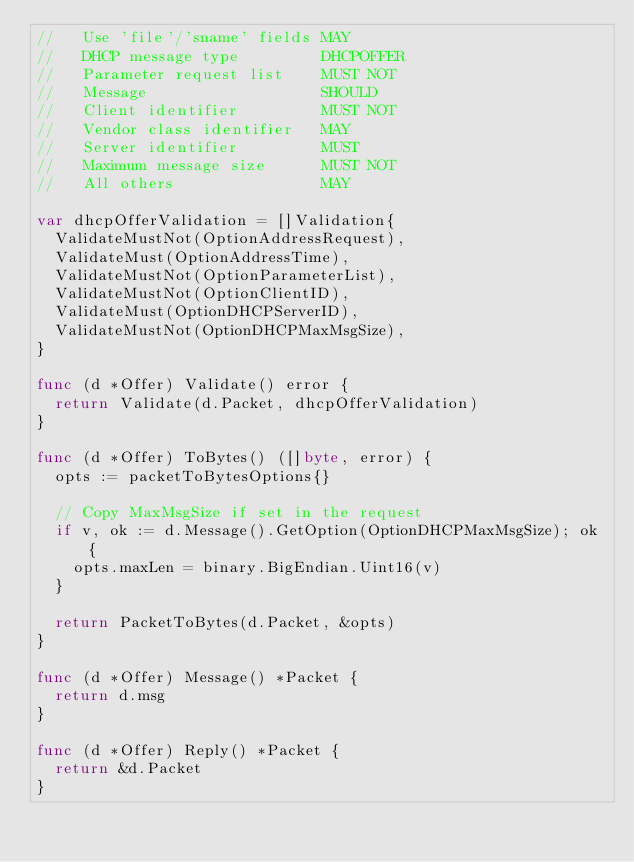Convert code to text. <code><loc_0><loc_0><loc_500><loc_500><_Go_>//   Use 'file'/'sname' fields MAY
//   DHCP message type         DHCPOFFER
//   Parameter request list    MUST NOT
//   Message                   SHOULD
//   Client identifier         MUST NOT
//   Vendor class identifier   MAY
//   Server identifier         MUST
//   Maximum message size      MUST NOT
//   All others                MAY

var dhcpOfferValidation = []Validation{
	ValidateMustNot(OptionAddressRequest),
	ValidateMust(OptionAddressTime),
	ValidateMustNot(OptionParameterList),
	ValidateMustNot(OptionClientID),
	ValidateMust(OptionDHCPServerID),
	ValidateMustNot(OptionDHCPMaxMsgSize),
}

func (d *Offer) Validate() error {
	return Validate(d.Packet, dhcpOfferValidation)
}

func (d *Offer) ToBytes() ([]byte, error) {
	opts := packetToBytesOptions{}

	// Copy MaxMsgSize if set in the request
	if v, ok := d.Message().GetOption(OptionDHCPMaxMsgSize); ok {
		opts.maxLen = binary.BigEndian.Uint16(v)
	}

	return PacketToBytes(d.Packet, &opts)
}

func (d *Offer) Message() *Packet {
	return d.msg
}

func (d *Offer) Reply() *Packet {
	return &d.Packet
}
</code> 